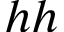<formula> <loc_0><loc_0><loc_500><loc_500>h h</formula> 